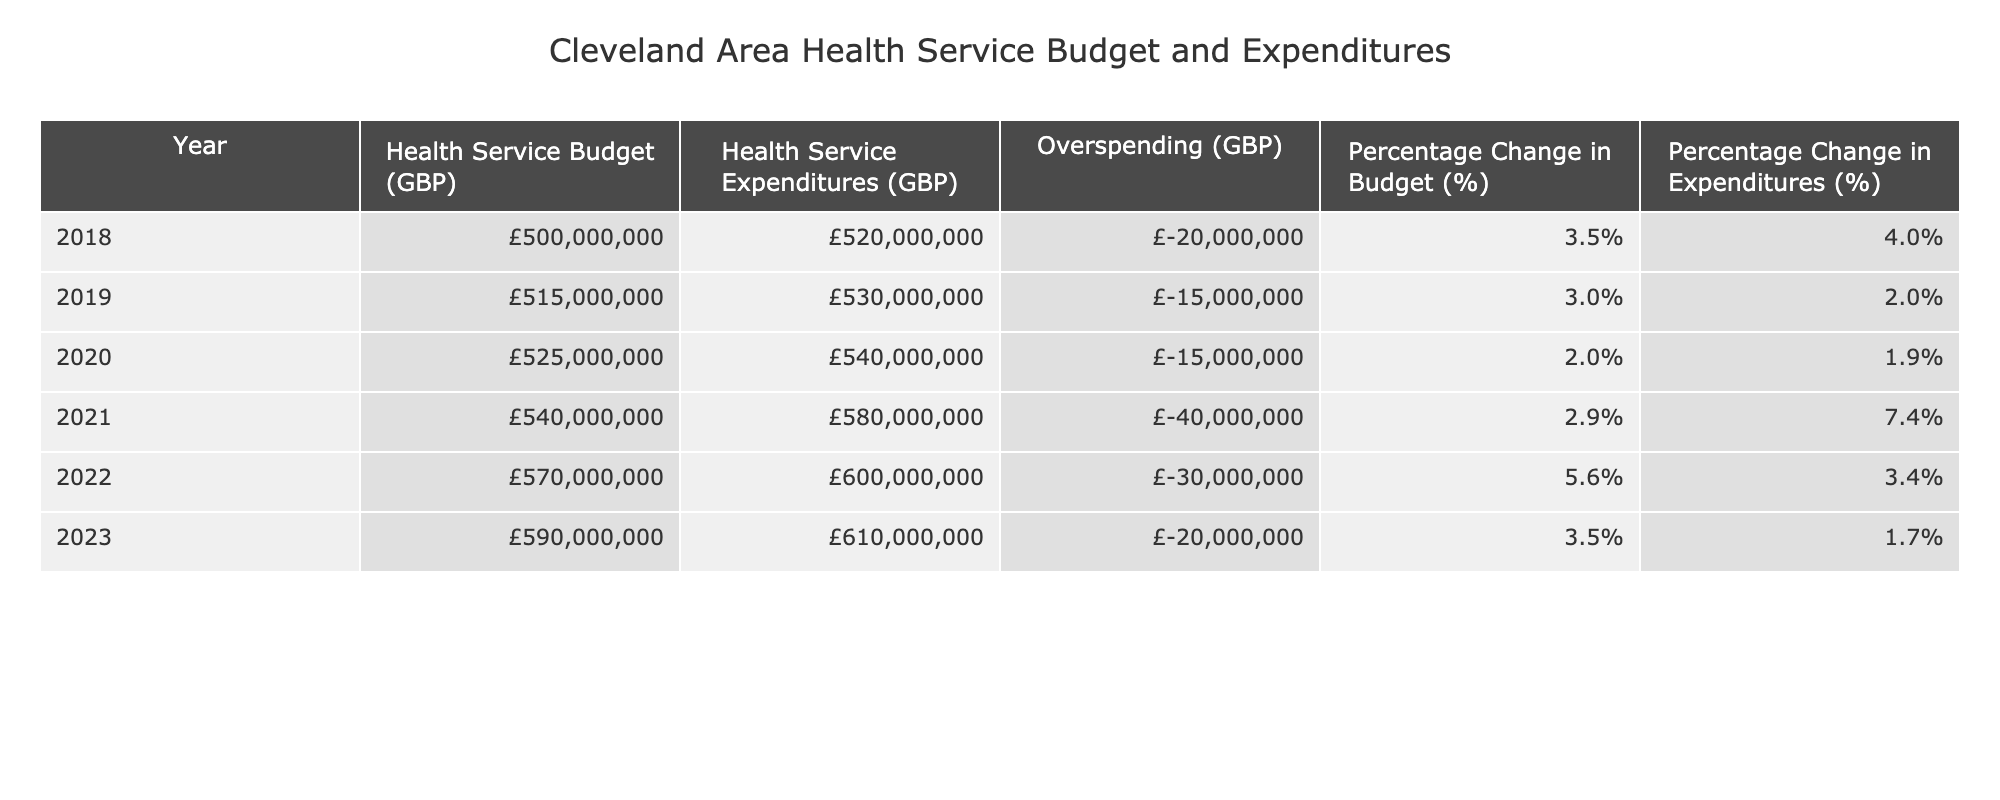What's the health service budget for 2022? The table shows the "Health Service Budget (GBP)" row for 2022, which is listed as £570,000,000.
Answer: £570,000,000 What was the health service expenditure in 2019? Referring to the table under the "Health Service Expenditures (GBP)" column for the year 2019, the value is £530,000,000.
Answer: £530,000,000 What is the amount of overspending in 2021? The row for 2021 in the "Overspending (GBP)" column indicates a value of -£40,000,000, which represents the overspending.
Answer: -£40,000,000 Which year showed the highest percentage change in expenditures? Looking at the "Percentage Change in Expenditures (%)" column, 2021 has the highest value at 7.4%.
Answer: 2021 How much more was spent than budgeted in 2020? The overspending for 2020 is calculated from the "Health Service Expenditures (GBP)" (£540,000,000) minus "Health Service Budget (GBP)" (£525,000,000), which results in £15,000,000 more spent.
Answer: £15,000,000 What is the total budget for the years 2018 to 2023? Summing the budgets from 2018 to 2023: £500,000,000 + £515,000,000 + £525,000,000 + £540,000,000 + £570,000,000 + £590,000,000 equals £2,740,000,000.
Answer: £2,740,000,000 Was there any year where expenditures decreased compared to the previous year? By examining the expenditures column, all entries show an increase year-over-year, confirming that no year had reduced expenditures.
Answer: No What was the difference in the budget growth between 2021 and 2022? The difference in the percentage change in budget from 2021 (2.9%) to 2022 (5.6%) is calculated as 5.6% - 2.9% = 2.7%.
Answer: 2.7% For how many years did Cleveland experience overspending over budget? The table shows that there were overspending values (negative) for every year listed from 2018 through 2023. Thus, all six years indicate overspending.
Answer: 6 years What was the average overspending over the recorded years? To find the average, sum the overspending amounts: -£20,000,000 - £15,000,000 - £15,000,000 - £40,000,000 - £30,000,000 - £20,000,000 which totals -£140,000,000. Dividing this by 6 gives an average overspending of -£23,333,333.33.
Answer: -£23,333,333.33 